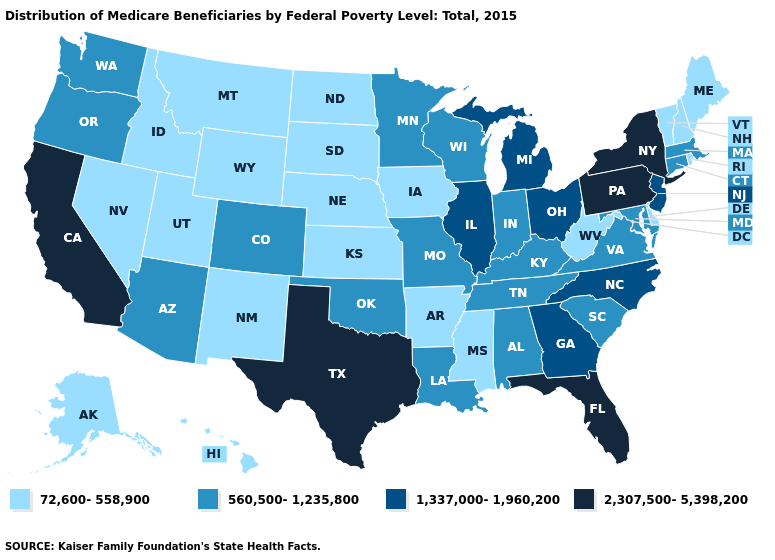What is the highest value in states that border South Carolina?
Short answer required. 1,337,000-1,960,200. Name the states that have a value in the range 2,307,500-5,398,200?
Answer briefly. California, Florida, New York, Pennsylvania, Texas. Does Illinois have the lowest value in the USA?
Give a very brief answer. No. Among the states that border Georgia , does North Carolina have the lowest value?
Keep it brief. No. Does the map have missing data?
Concise answer only. No. Name the states that have a value in the range 2,307,500-5,398,200?
Concise answer only. California, Florida, New York, Pennsylvania, Texas. Among the states that border Colorado , does Wyoming have the lowest value?
Concise answer only. Yes. Name the states that have a value in the range 1,337,000-1,960,200?
Answer briefly. Georgia, Illinois, Michigan, New Jersey, North Carolina, Ohio. What is the value of South Dakota?
Concise answer only. 72,600-558,900. Does Nebraska have the lowest value in the MidWest?
Write a very short answer. Yes. Among the states that border Connecticut , which have the highest value?
Concise answer only. New York. How many symbols are there in the legend?
Be succinct. 4. Among the states that border Vermont , does New York have the highest value?
Short answer required. Yes. How many symbols are there in the legend?
Quick response, please. 4. Which states have the lowest value in the Northeast?
Short answer required. Maine, New Hampshire, Rhode Island, Vermont. 